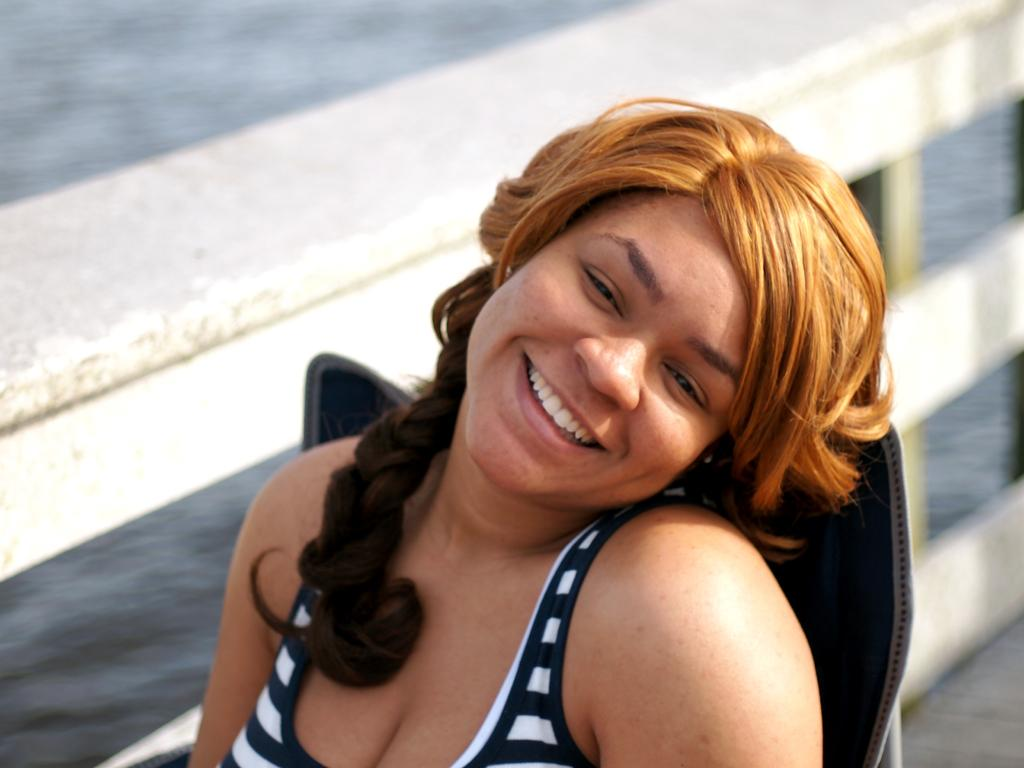Who is present in the image? There is a woman in the image. What expression does the woman have? The woman is smiling. What can be seen in the background of the image? There is a fence and water visible in the background of the image. What type of calculator is the woman using in the image? There is no calculator present in the image. Is the woman in a prison cell in the image? There is no indication of a prison cell or any confinement in the image; it simply features a woman smiling with a fence and water in the background. 